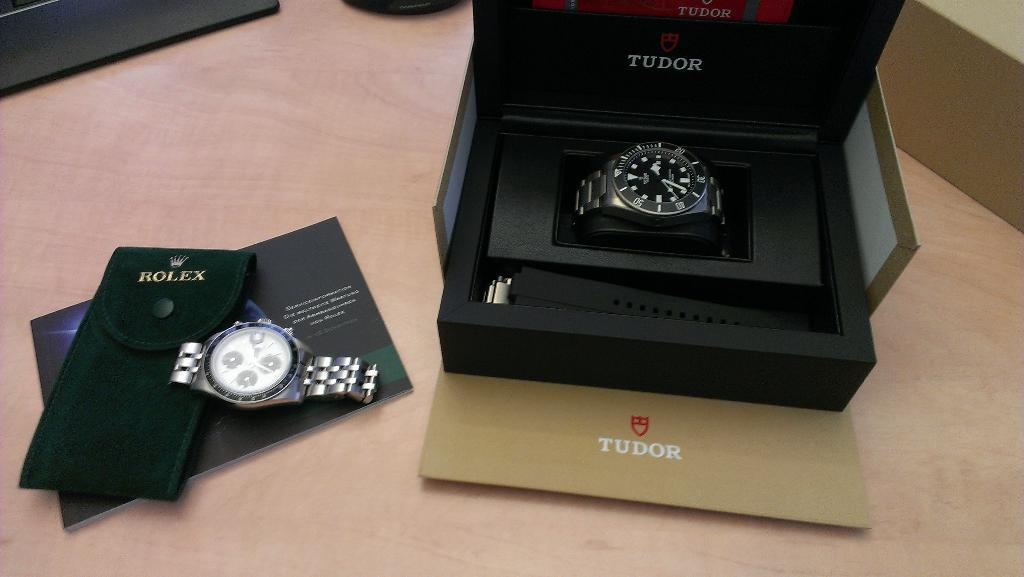<image>
Present a compact description of the photo's key features. A watch is in a black box with the Tudor logo in front of it. 